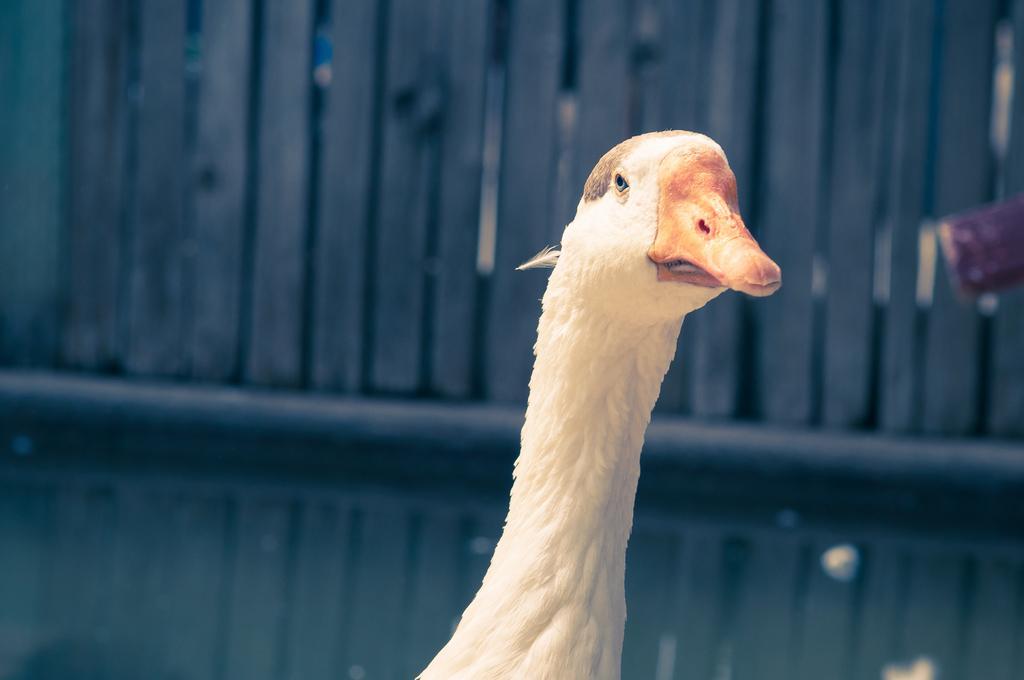How would you summarize this image in a sentence or two? In this picture I can see a goose and I can see fence in the back. 